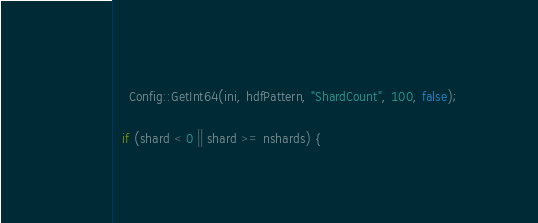Convert code to text. <code><loc_0><loc_0><loc_500><loc_500><_C++_>    Config::GetInt64(ini, hdfPattern, "ShardCount", 100, false);

  if (shard < 0 || shard >= nshards) {</code> 